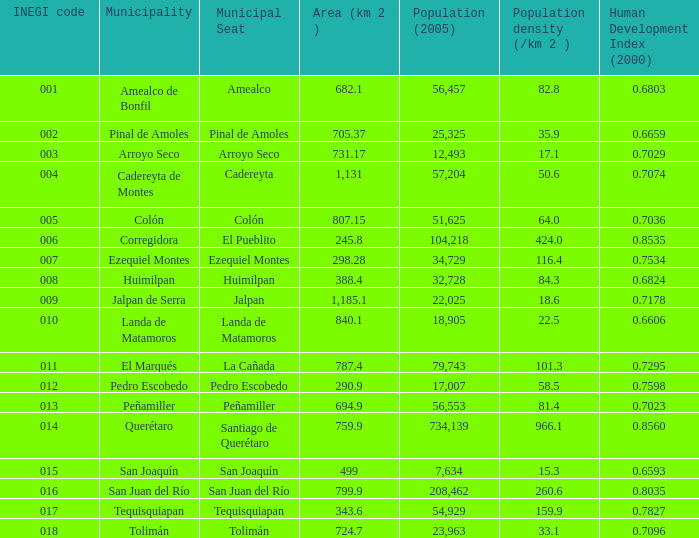WHat is the amount of Human Development Index (2000) that has a Population (2005) of 54,929, and an Area (km 2 ) larger than 343.6? 0.0. 